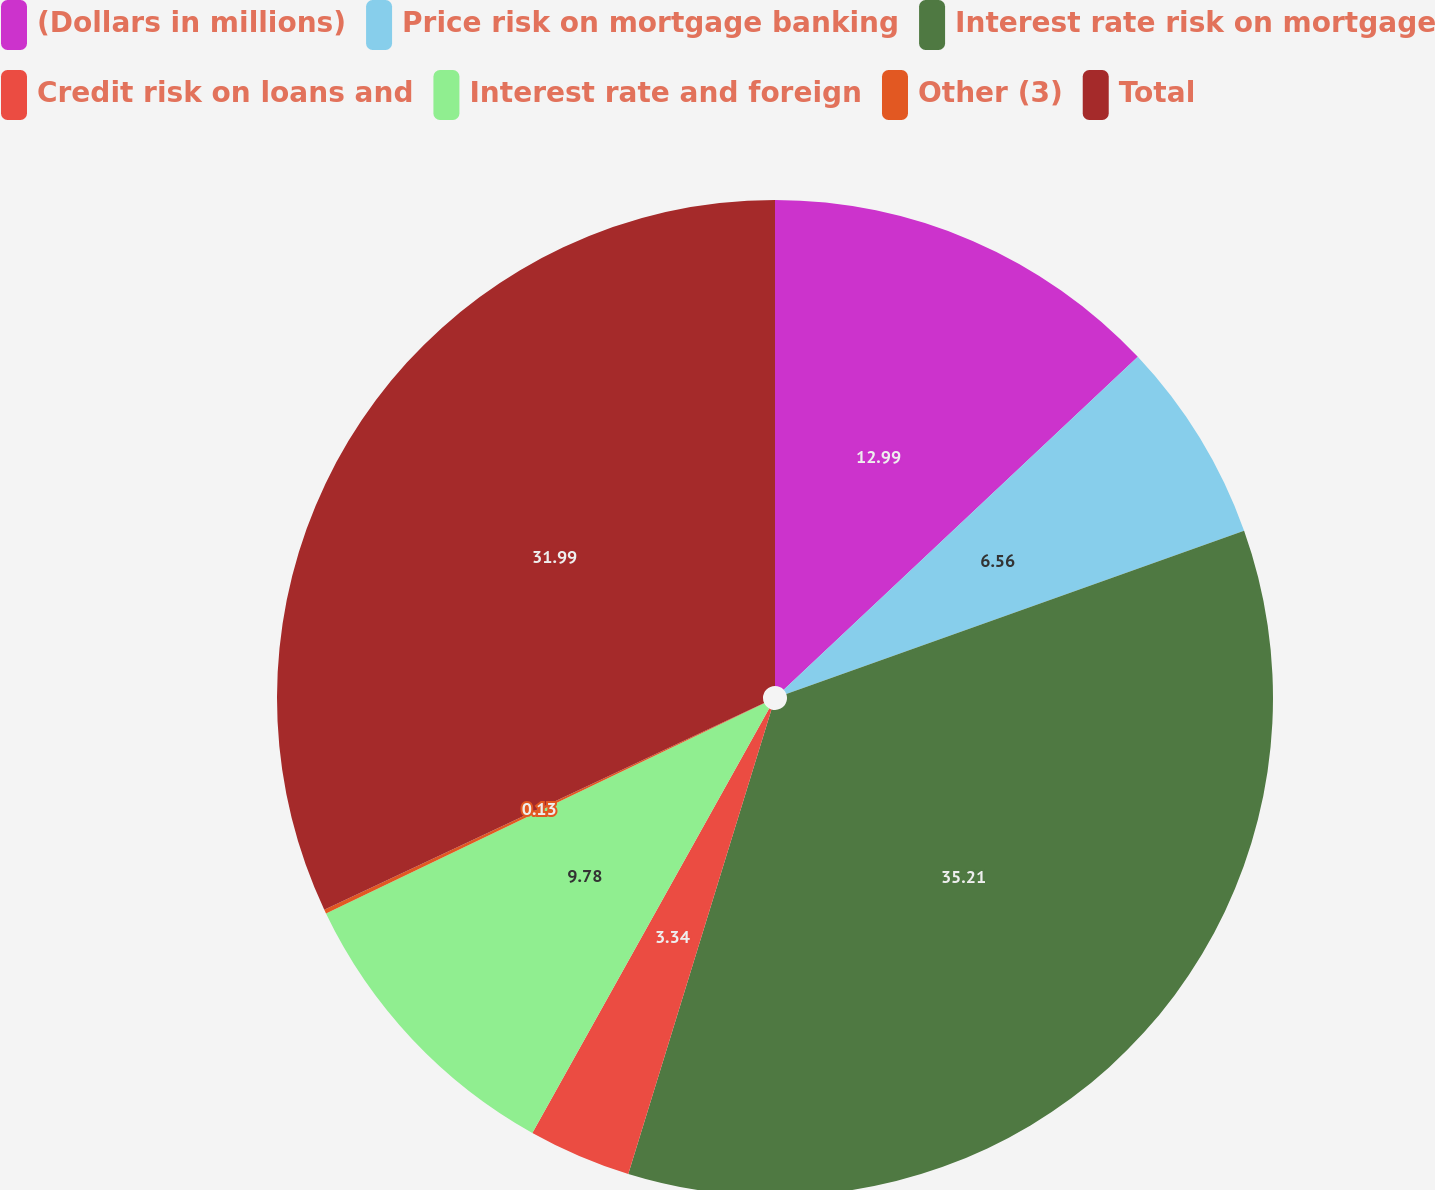Convert chart to OTSL. <chart><loc_0><loc_0><loc_500><loc_500><pie_chart><fcel>(Dollars in millions)<fcel>Price risk on mortgage banking<fcel>Interest rate risk on mortgage<fcel>Credit risk on loans and<fcel>Interest rate and foreign<fcel>Other (3)<fcel>Total<nl><fcel>12.99%<fcel>6.56%<fcel>35.21%<fcel>3.34%<fcel>9.78%<fcel>0.13%<fcel>31.99%<nl></chart> 